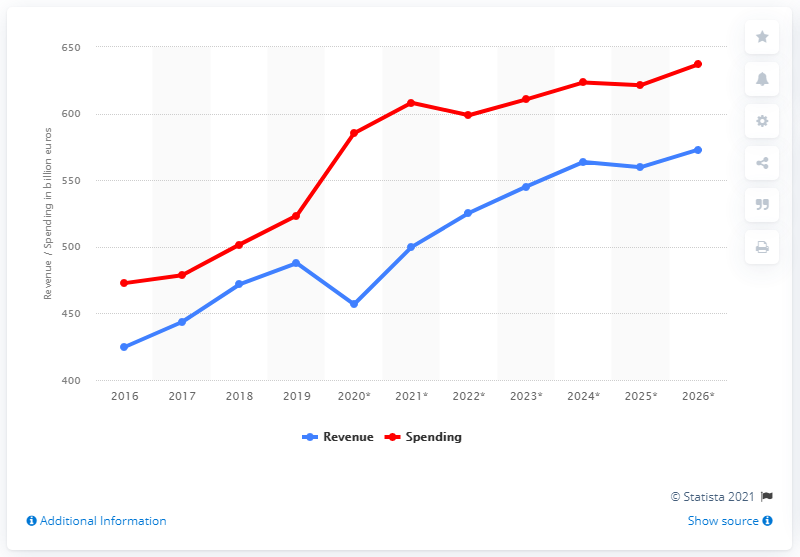Specify some key components in this picture. In 2019, Spain's government revenue was 487.8 billion euros. In 2019, the government of Spain spent approximately 525.39 billion euros. 